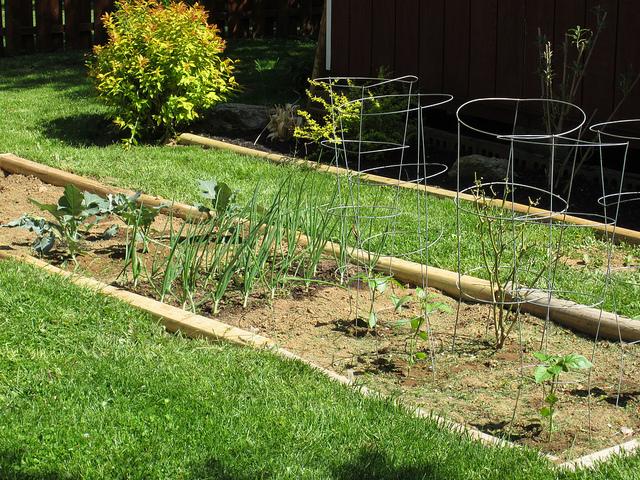What color is the grass?
Quick response, please. Green. What are the metal structures used for?
Concise answer only. Tomatoes. Are there any shrubs in the picture?
Give a very brief answer. Yes. 